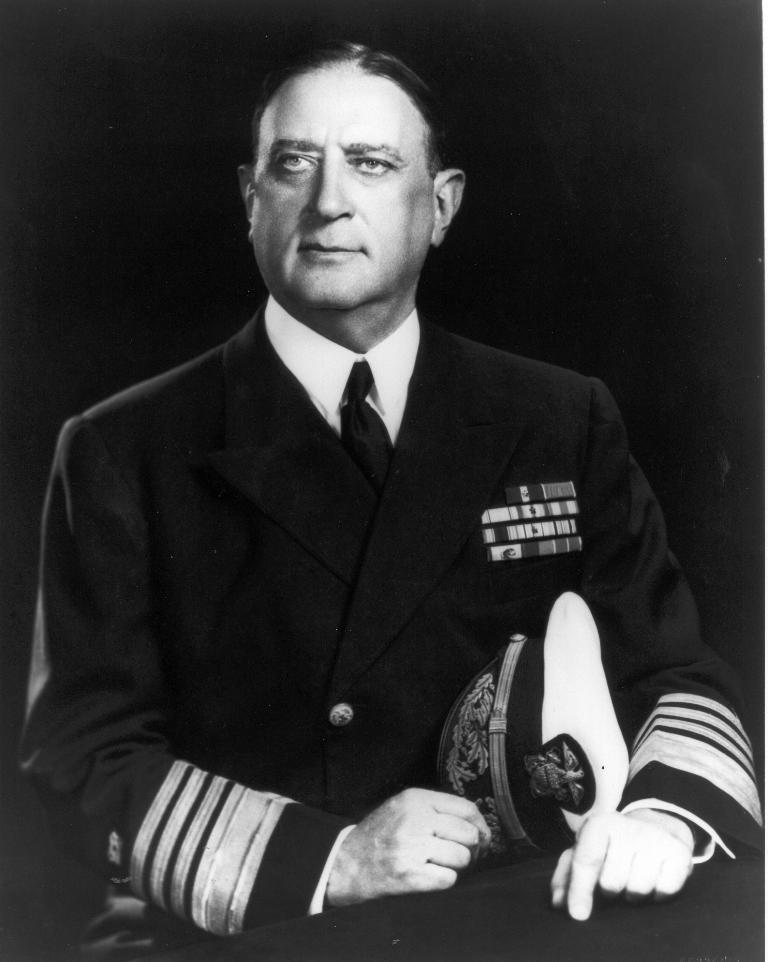What is the color scheme of the image? The image is black and white. Who is present in the image? There is a man in the image. What is the man wearing? The man is wearing a suit. What is the man holding in his hand? The man is holding a cap in his hand. What is the man's posture in the image? The man is sitting. In which direction is the man looking? The man is looking towards the left side. What can be observed about the background of the image? The background is black. What type of soap is the man using to teach in the image? There is no soap or teaching activity present in the image. What is the man's role in the birth of the baby in the image? There is no baby or birth depicted in the image; it features a man sitting and looking towards the left side. 